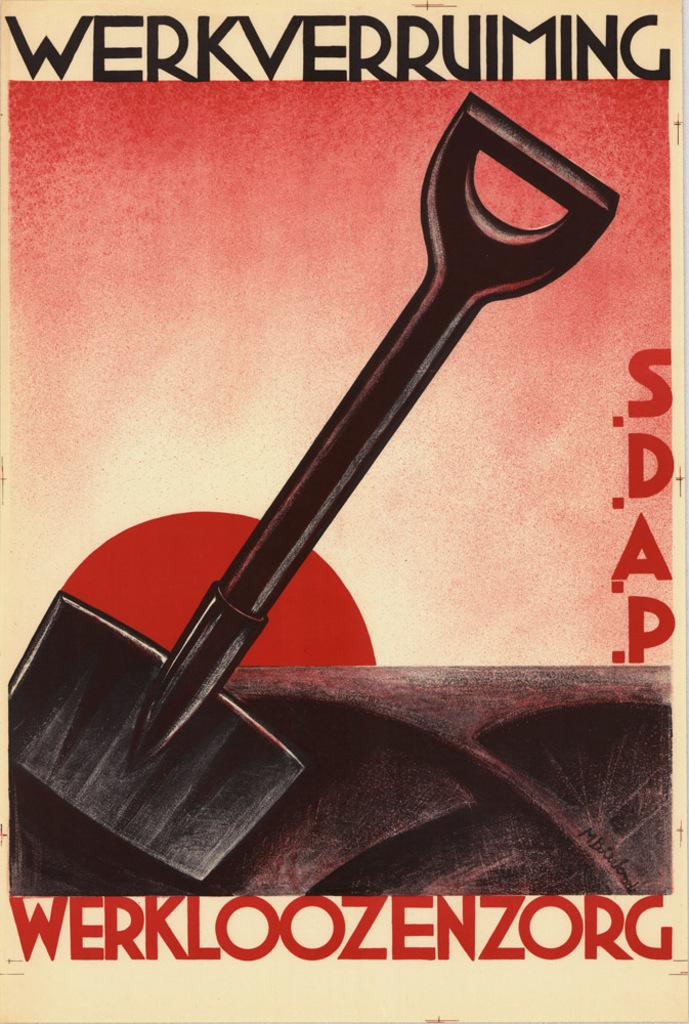What is present on the poster in the image? The poster contains text and an image. Can you describe the image on the poster? Unfortunately, the specific image on the poster cannot be described with the given facts. What is the purpose of the text on the poster? The purpose of the text on the poster cannot be determined with the given facts. How many bricks are stacked on the left side of the poster? There are no bricks present in the image, as the image only contains a poster with text and an image. 